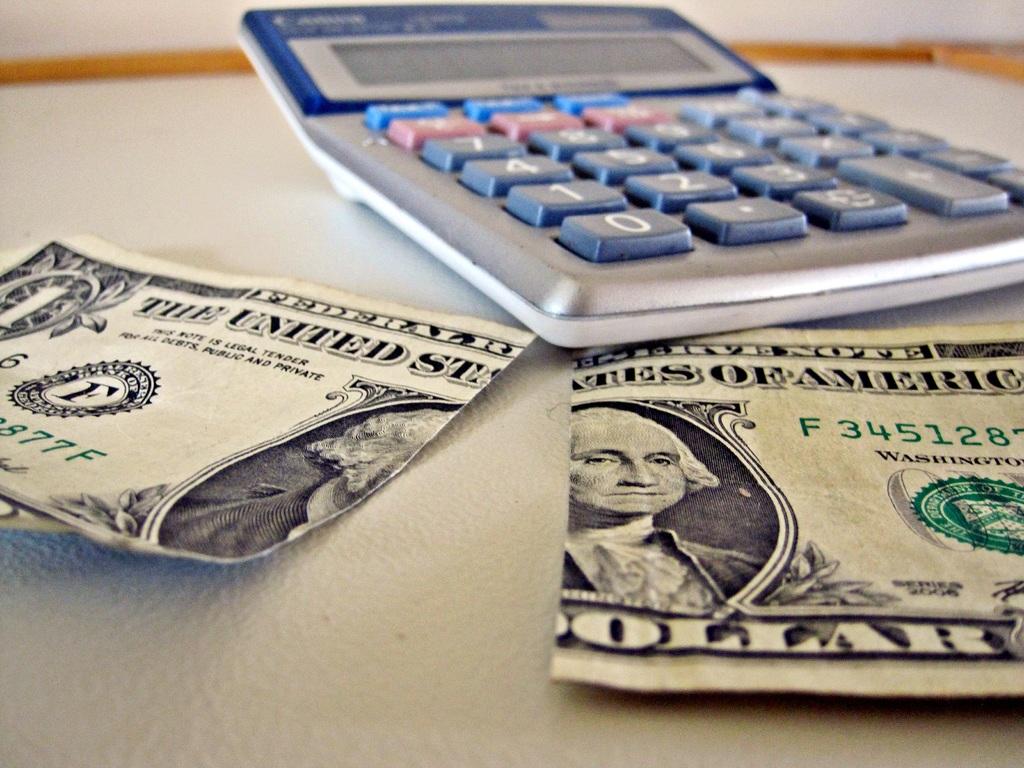How much is that bill?
Your answer should be compact. One dollar. 